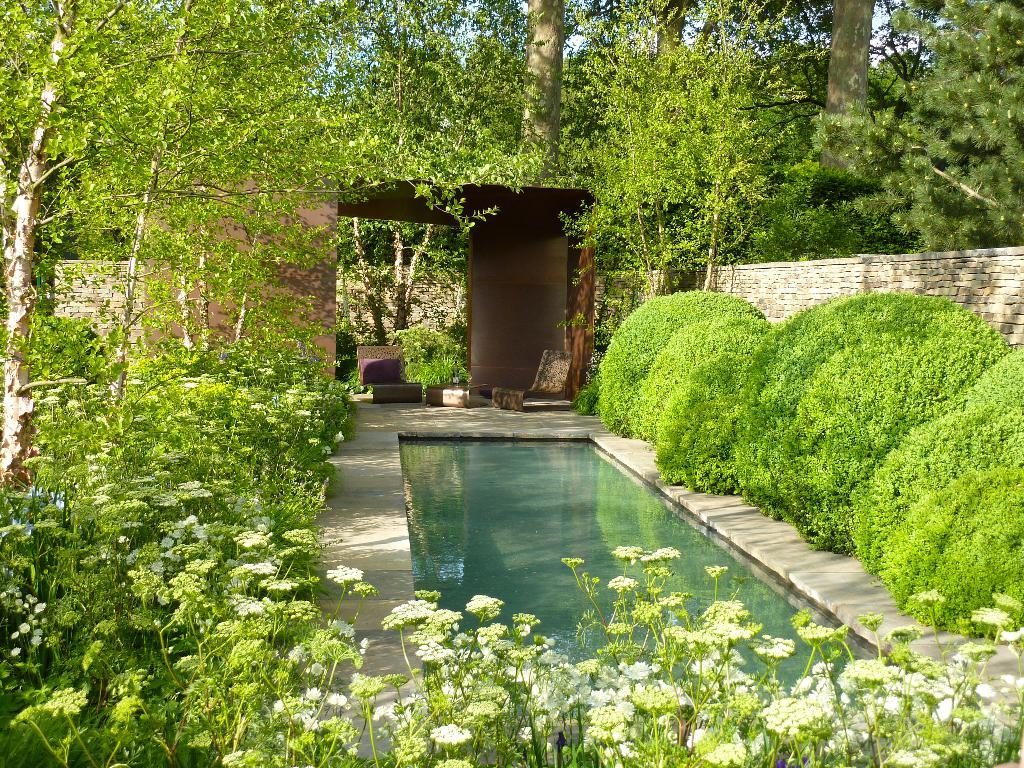What types of vegetation can be seen in the image? Plants and flowers are visible in the image. What is the primary element present in the image? Water is visible in the image. What is the maid doing in the image? There is no maid present in the image. Is the uncle holding an umbrella in the image? There is no uncle or any indication of rain in the image. 